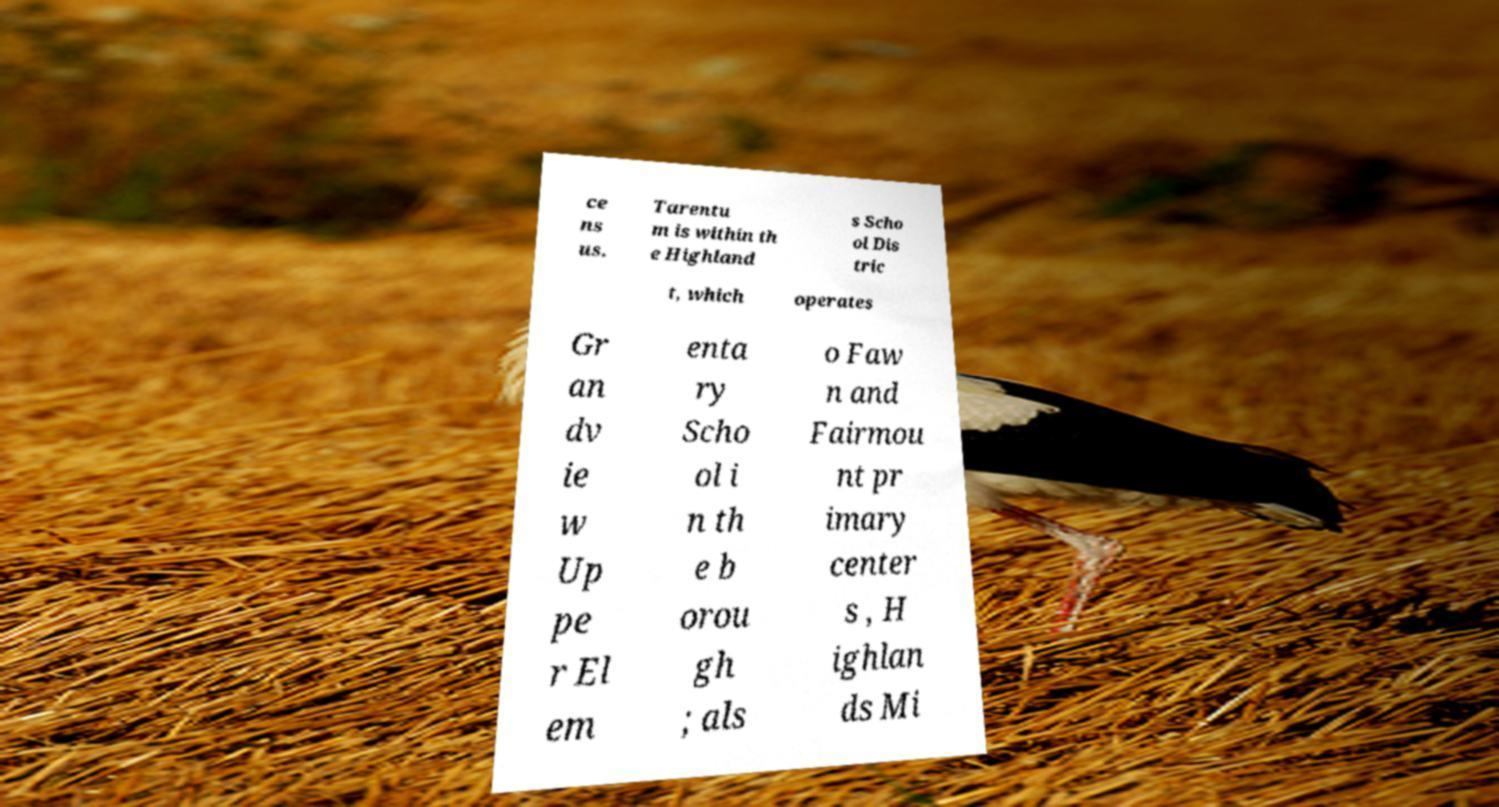Could you assist in decoding the text presented in this image and type it out clearly? ce ns us. Tarentu m is within th e Highland s Scho ol Dis tric t, which operates Gr an dv ie w Up pe r El em enta ry Scho ol i n th e b orou gh ; als o Faw n and Fairmou nt pr imary center s , H ighlan ds Mi 